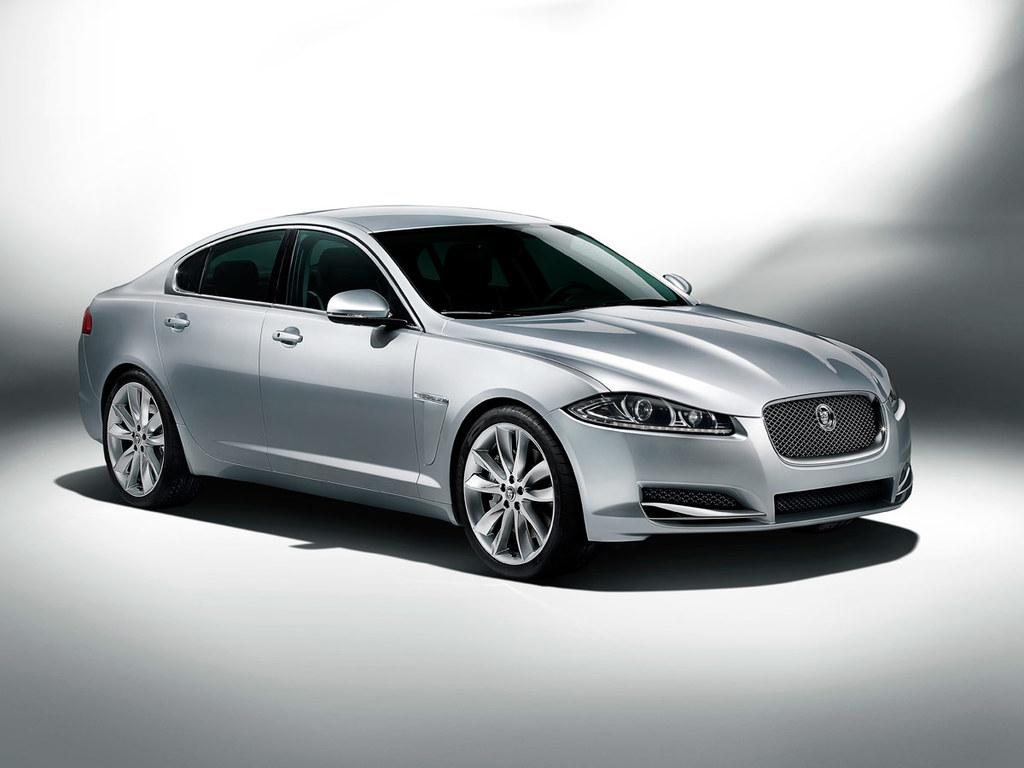What is the main subject of the image? The main subject of the image is a car. Can you describe the surface on which the car is located? The car is on a white surface. How many ducks are sitting on the car in the image? There are no ducks present in the image; it only features a car on a white surface. What type of stretch can be seen on the car's nose in the image? There is no stretch or nose on the car in the image, as it is a car and not a living being. 